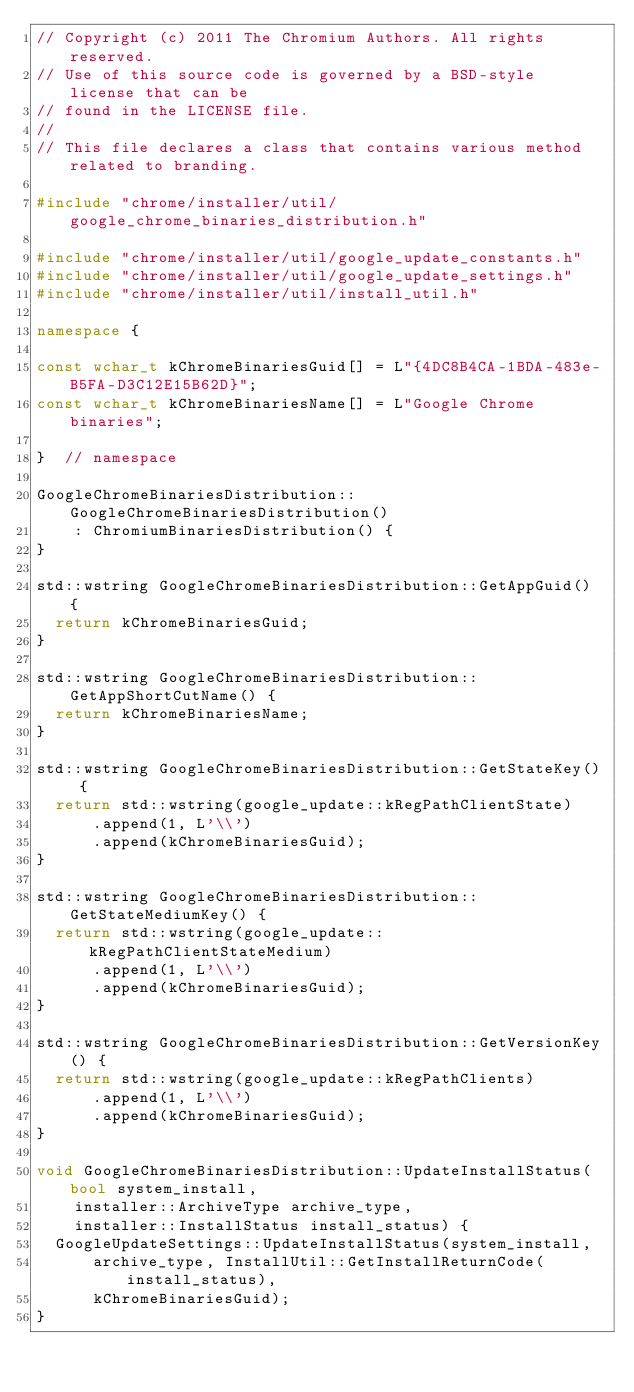<code> <loc_0><loc_0><loc_500><loc_500><_C++_>// Copyright (c) 2011 The Chromium Authors. All rights reserved.
// Use of this source code is governed by a BSD-style license that can be
// found in the LICENSE file.
//
// This file declares a class that contains various method related to branding.

#include "chrome/installer/util/google_chrome_binaries_distribution.h"

#include "chrome/installer/util/google_update_constants.h"
#include "chrome/installer/util/google_update_settings.h"
#include "chrome/installer/util/install_util.h"

namespace {

const wchar_t kChromeBinariesGuid[] = L"{4DC8B4CA-1BDA-483e-B5FA-D3C12E15B62D}";
const wchar_t kChromeBinariesName[] = L"Google Chrome binaries";

}  // namespace

GoogleChromeBinariesDistribution::GoogleChromeBinariesDistribution()
    : ChromiumBinariesDistribution() {
}

std::wstring GoogleChromeBinariesDistribution::GetAppGuid() {
  return kChromeBinariesGuid;
}

std::wstring GoogleChromeBinariesDistribution::GetAppShortCutName() {
  return kChromeBinariesName;
}

std::wstring GoogleChromeBinariesDistribution::GetStateKey() {
  return std::wstring(google_update::kRegPathClientState)
      .append(1, L'\\')
      .append(kChromeBinariesGuid);
}

std::wstring GoogleChromeBinariesDistribution::GetStateMediumKey() {
  return std::wstring(google_update::kRegPathClientStateMedium)
      .append(1, L'\\')
      .append(kChromeBinariesGuid);
}

std::wstring GoogleChromeBinariesDistribution::GetVersionKey() {
  return std::wstring(google_update::kRegPathClients)
      .append(1, L'\\')
      .append(kChromeBinariesGuid);
}

void GoogleChromeBinariesDistribution::UpdateInstallStatus(bool system_install,
    installer::ArchiveType archive_type,
    installer::InstallStatus install_status) {
  GoogleUpdateSettings::UpdateInstallStatus(system_install,
      archive_type, InstallUtil::GetInstallReturnCode(install_status),
      kChromeBinariesGuid);
}
</code> 